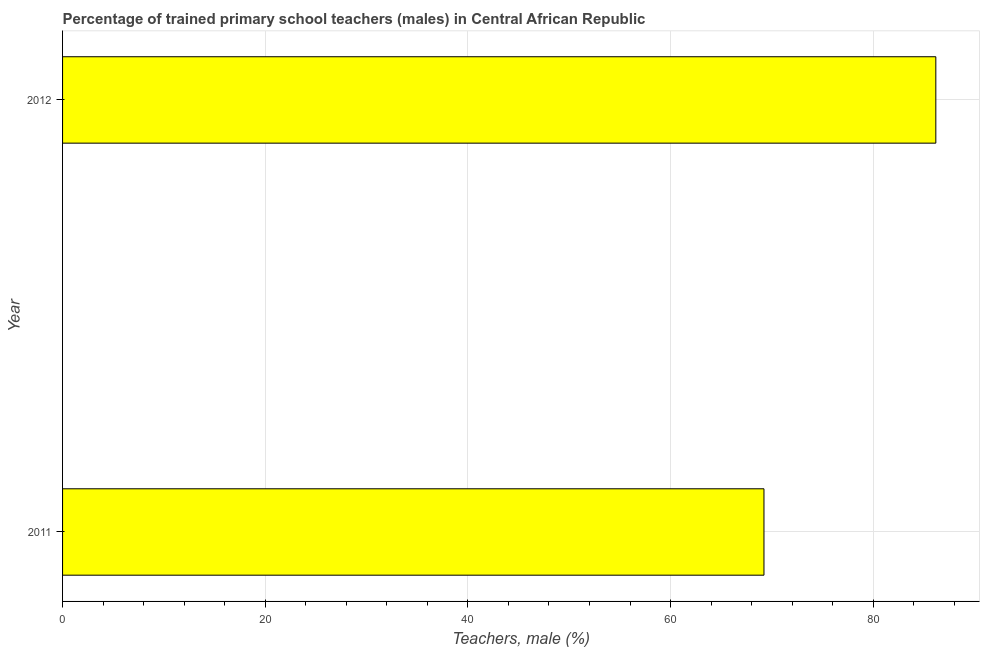Does the graph contain grids?
Keep it short and to the point. Yes. What is the title of the graph?
Offer a terse response. Percentage of trained primary school teachers (males) in Central African Republic. What is the label or title of the X-axis?
Make the answer very short. Teachers, male (%). What is the percentage of trained male teachers in 2011?
Your answer should be compact. 69.21. Across all years, what is the maximum percentage of trained male teachers?
Your answer should be very brief. 86.17. Across all years, what is the minimum percentage of trained male teachers?
Keep it short and to the point. 69.21. What is the sum of the percentage of trained male teachers?
Your response must be concise. 155.39. What is the difference between the percentage of trained male teachers in 2011 and 2012?
Give a very brief answer. -16.96. What is the average percentage of trained male teachers per year?
Your response must be concise. 77.69. What is the median percentage of trained male teachers?
Offer a terse response. 77.69. Do a majority of the years between 2011 and 2012 (inclusive) have percentage of trained male teachers greater than 4 %?
Make the answer very short. Yes. What is the ratio of the percentage of trained male teachers in 2011 to that in 2012?
Your answer should be very brief. 0.8. In how many years, is the percentage of trained male teachers greater than the average percentage of trained male teachers taken over all years?
Your response must be concise. 1. How many bars are there?
Offer a terse response. 2. Are all the bars in the graph horizontal?
Offer a very short reply. Yes. How many years are there in the graph?
Keep it short and to the point. 2. What is the difference between two consecutive major ticks on the X-axis?
Ensure brevity in your answer.  20. What is the Teachers, male (%) of 2011?
Give a very brief answer. 69.21. What is the Teachers, male (%) of 2012?
Ensure brevity in your answer.  86.17. What is the difference between the Teachers, male (%) in 2011 and 2012?
Give a very brief answer. -16.96. What is the ratio of the Teachers, male (%) in 2011 to that in 2012?
Keep it short and to the point. 0.8. 